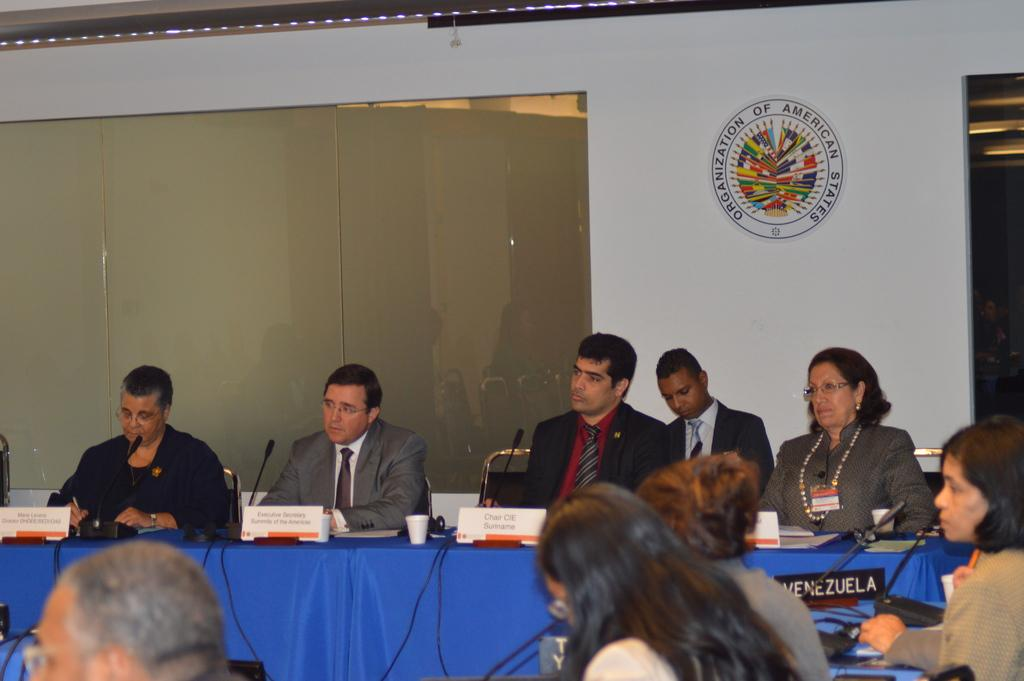What are the persons in the image doing? The persons in the image are sitting on chairs. What is the main object in the center of the image? There is a table in the image. What items can be seen on the table? There is a name board, a microphone, a cup, a cloth, and a cable on the table. What can be seen in the background of the image? There is a wall and a glass window in the background. Can you see any wrens in the image? There are no wrens present in the image. Are there any mittens on the table in the image? There are no mittens present in the image. 